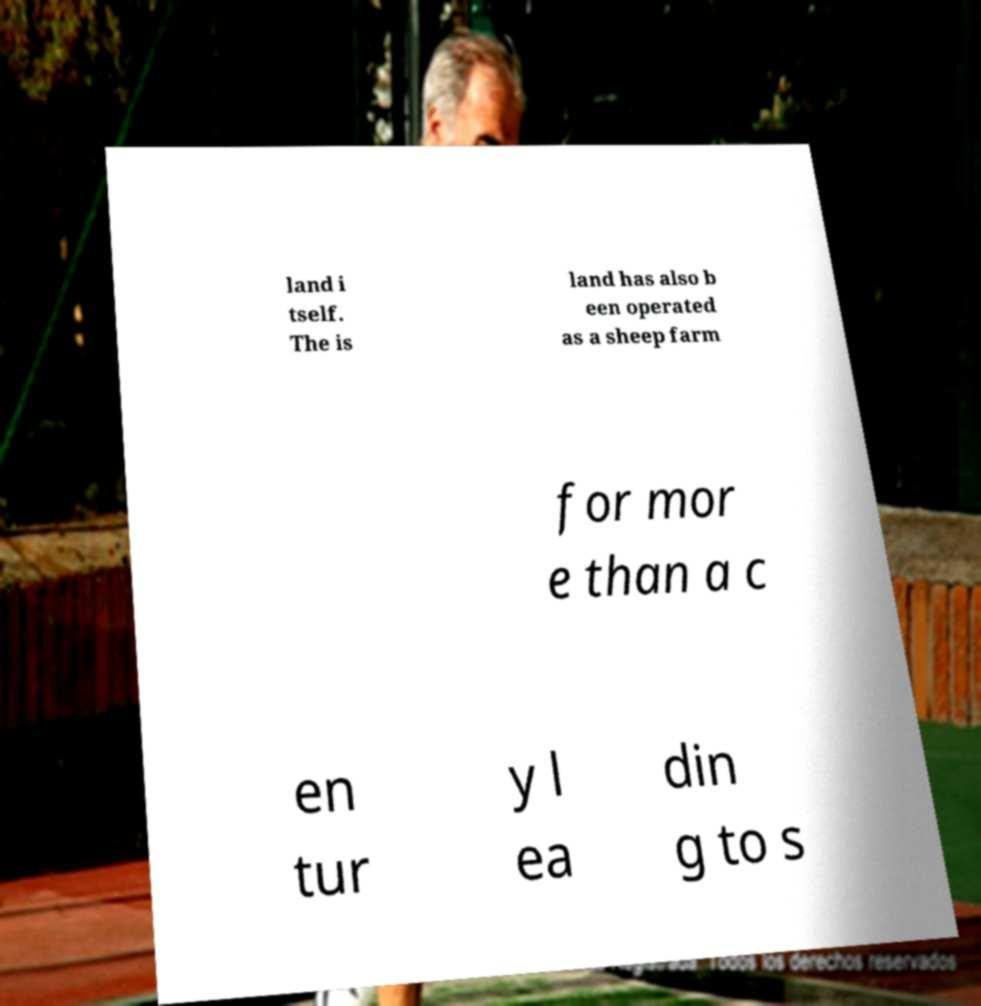Can you accurately transcribe the text from the provided image for me? land i tself. The is land has also b een operated as a sheep farm for mor e than a c en tur y l ea din g to s 